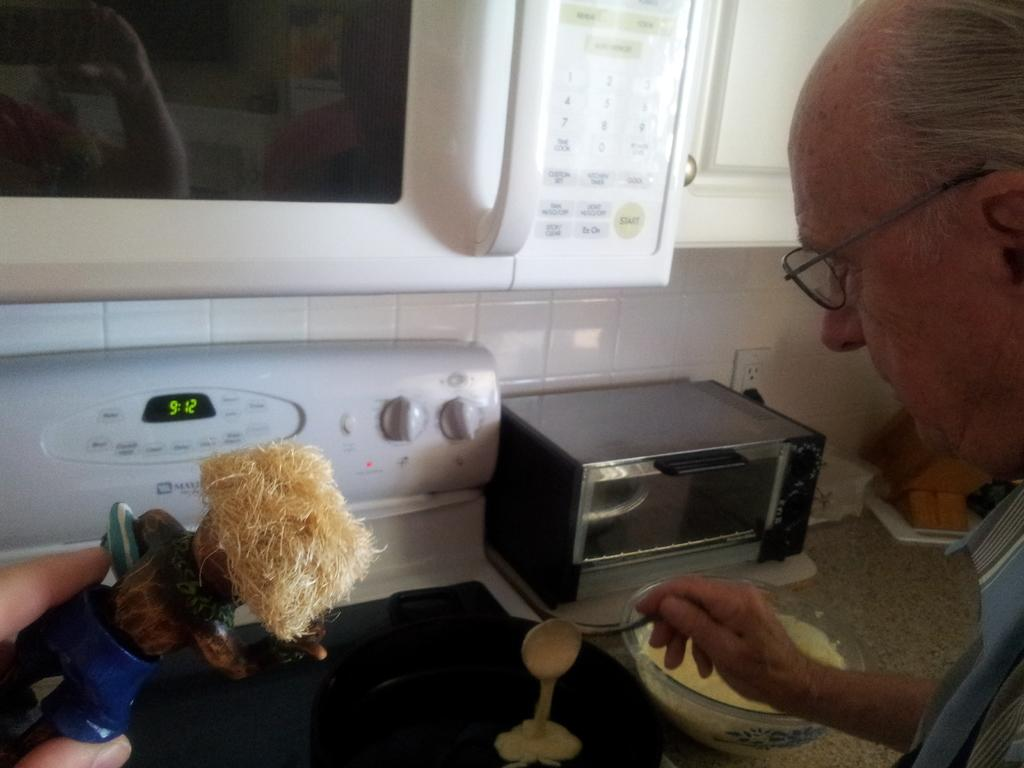<image>
Give a short and clear explanation of the subsequent image. An old man is ladling a pancake mix onto the pan at 9:12 AM. 